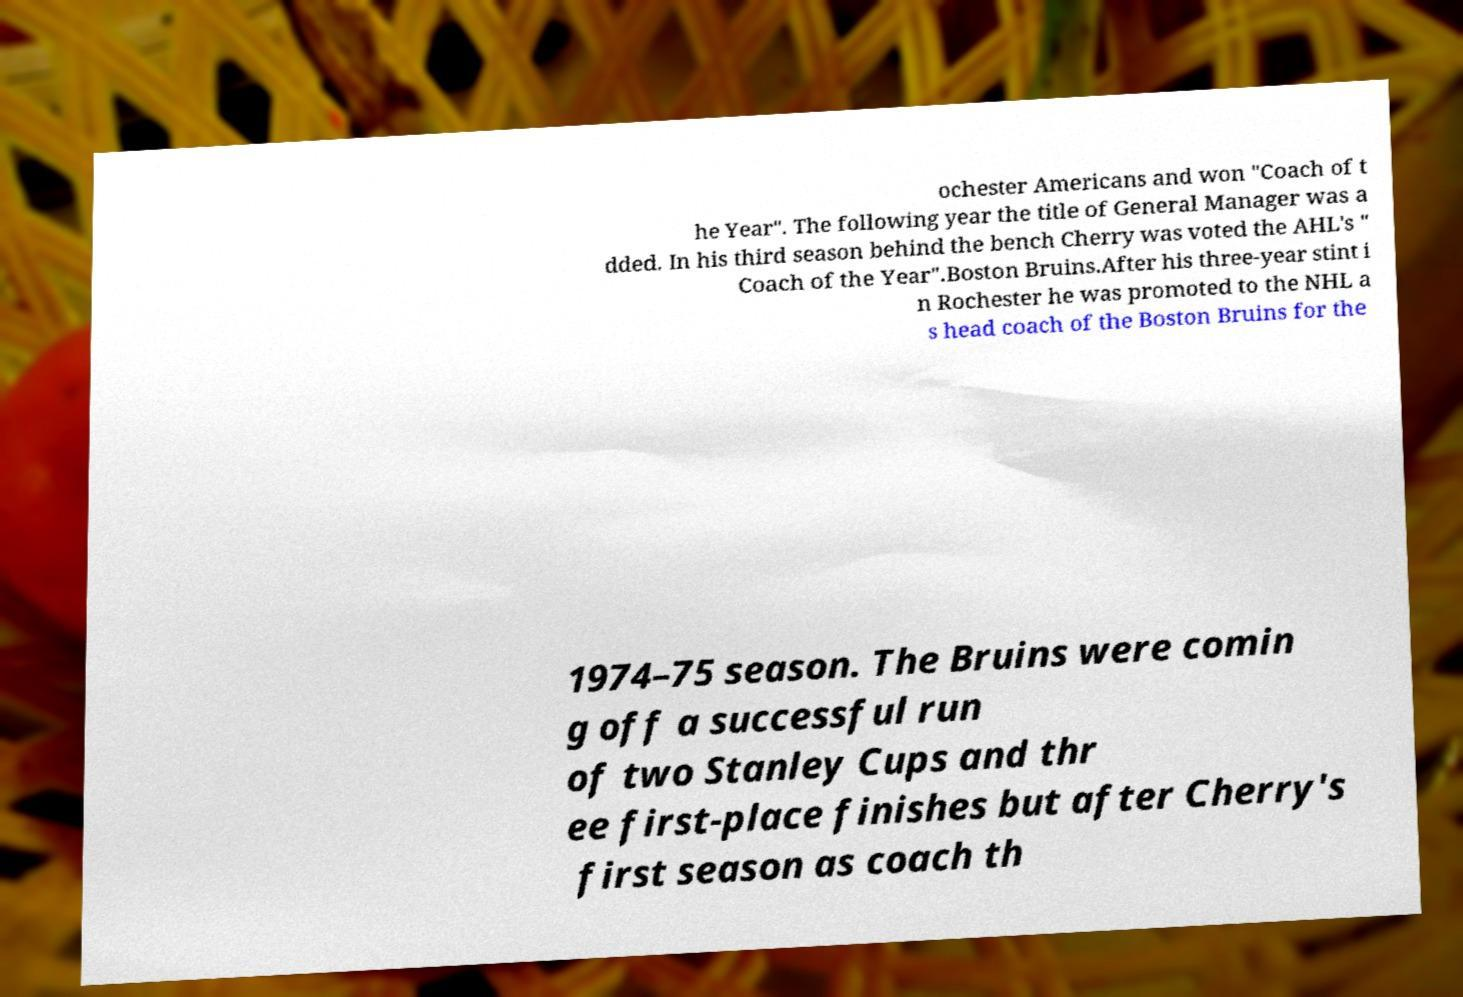Please read and relay the text visible in this image. What does it say? ochester Americans and won "Coach of t he Year". The following year the title of General Manager was a dded. In his third season behind the bench Cherry was voted the AHL's " Coach of the Year".Boston Bruins.After his three-year stint i n Rochester he was promoted to the NHL a s head coach of the Boston Bruins for the 1974–75 season. The Bruins were comin g off a successful run of two Stanley Cups and thr ee first-place finishes but after Cherry's first season as coach th 